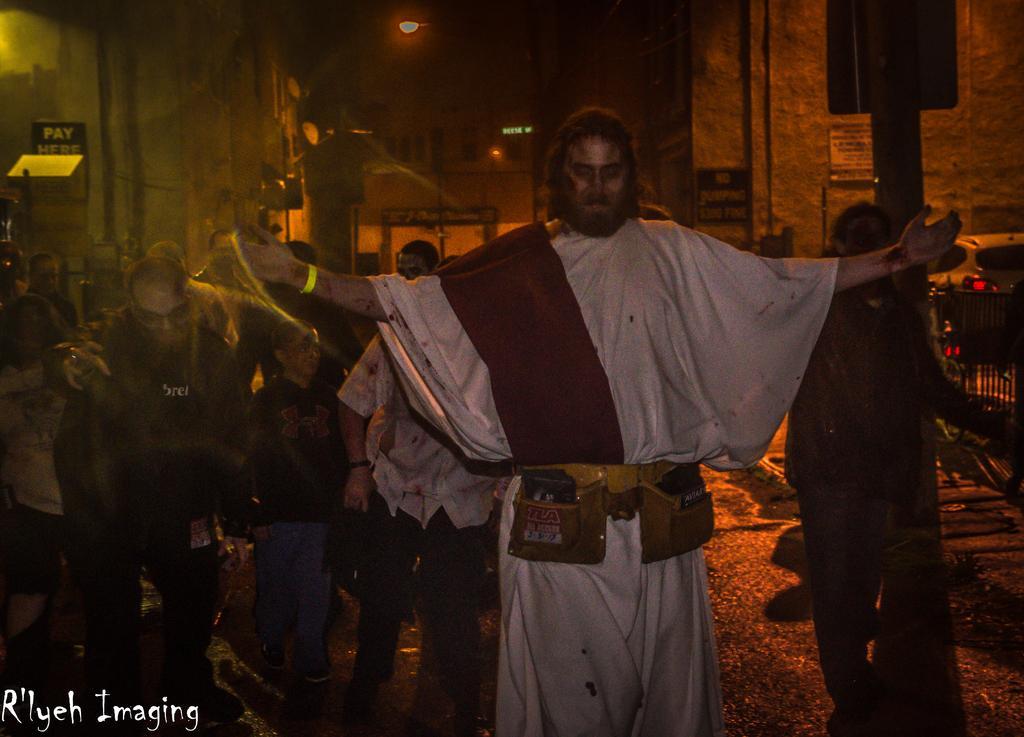Could you give a brief overview of what you see in this image? Here in this picture we can see number of people standing on the road over there and each and everyone is portraying some cosplay on him and behind him we can see buildings present over there and we can see light posts and sign boards present here and there. 